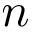Convert formula to latex. <formula><loc_0><loc_0><loc_500><loc_500>n</formula> 